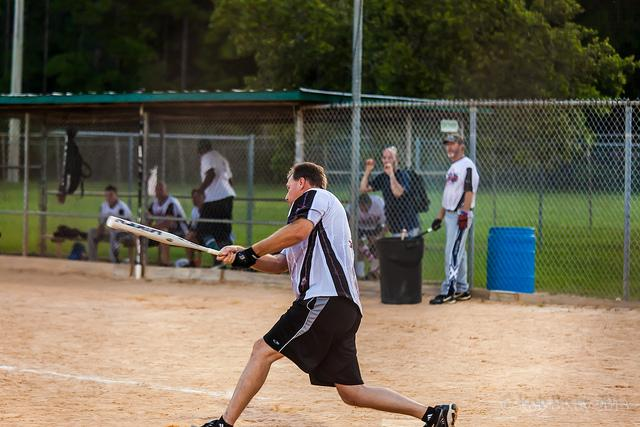What is the most common usage of the black container? trash 